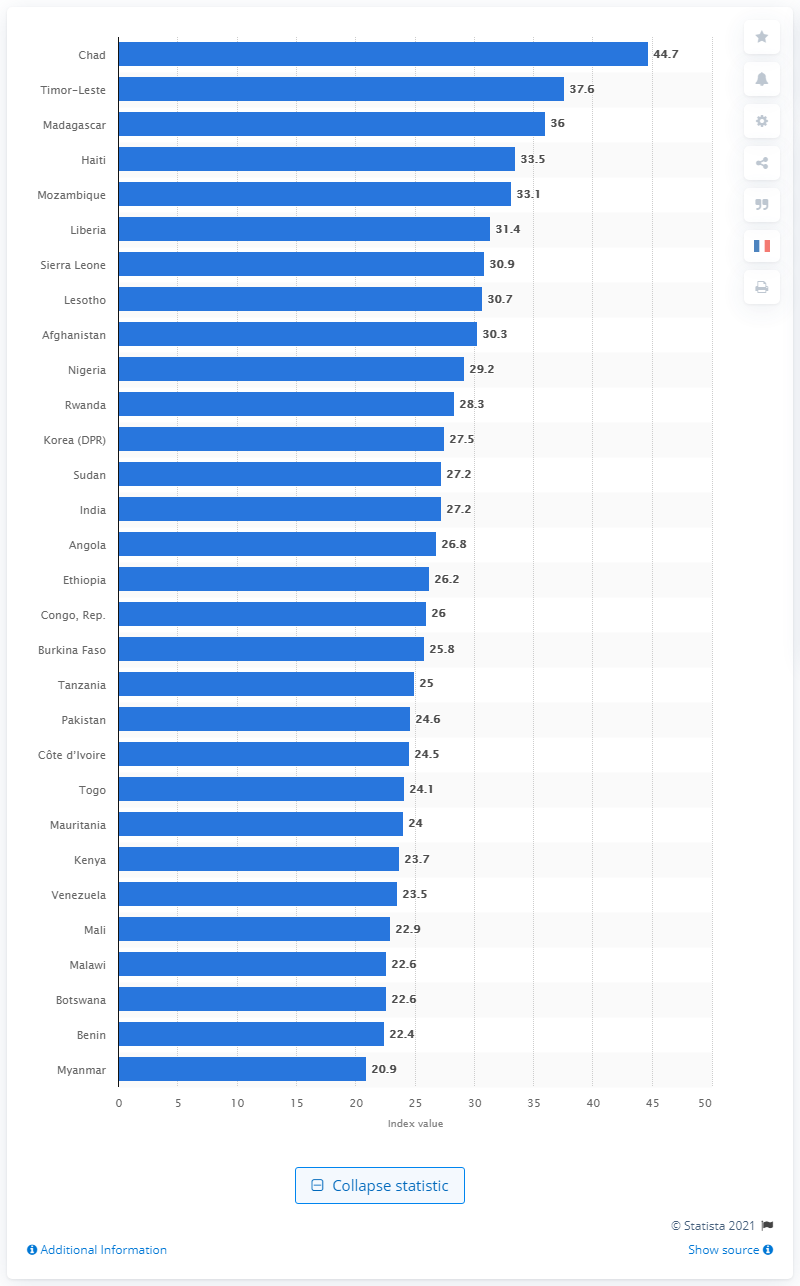Outline some significant characteristics in this image. Timor-Leste's score on the Human Development Index for 2021 was 37.6, indicating a medium level of human development. The Global Hunger Index 2020 was 44.7, indicating a moderate level of hunger and food insecurity in the world. 